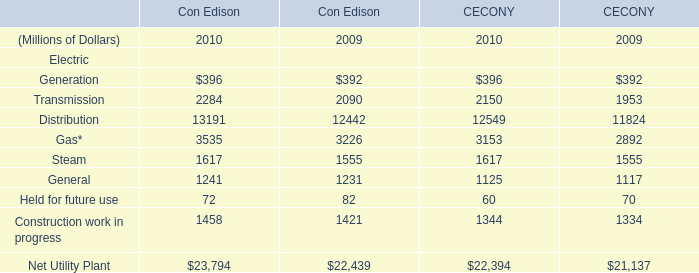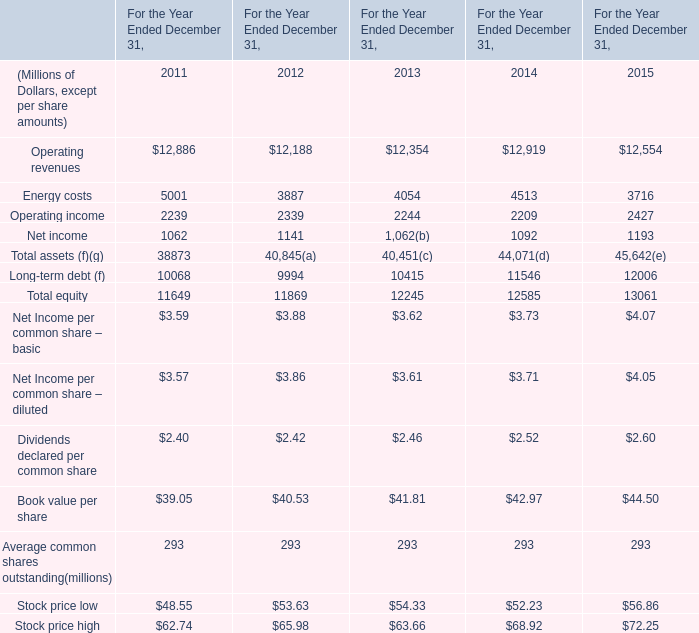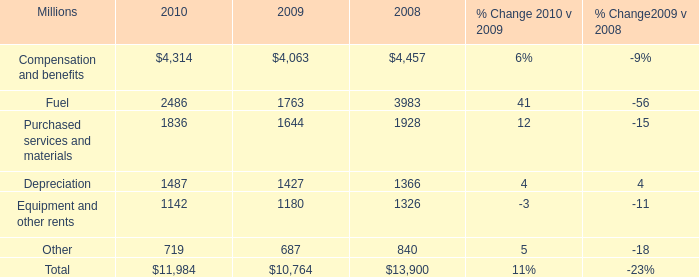what was the percentage increase for diesel fuel prices from 2009 to 2010? 
Computations: ((2.29 - 1.75) / 1.75)
Answer: 0.30857. 